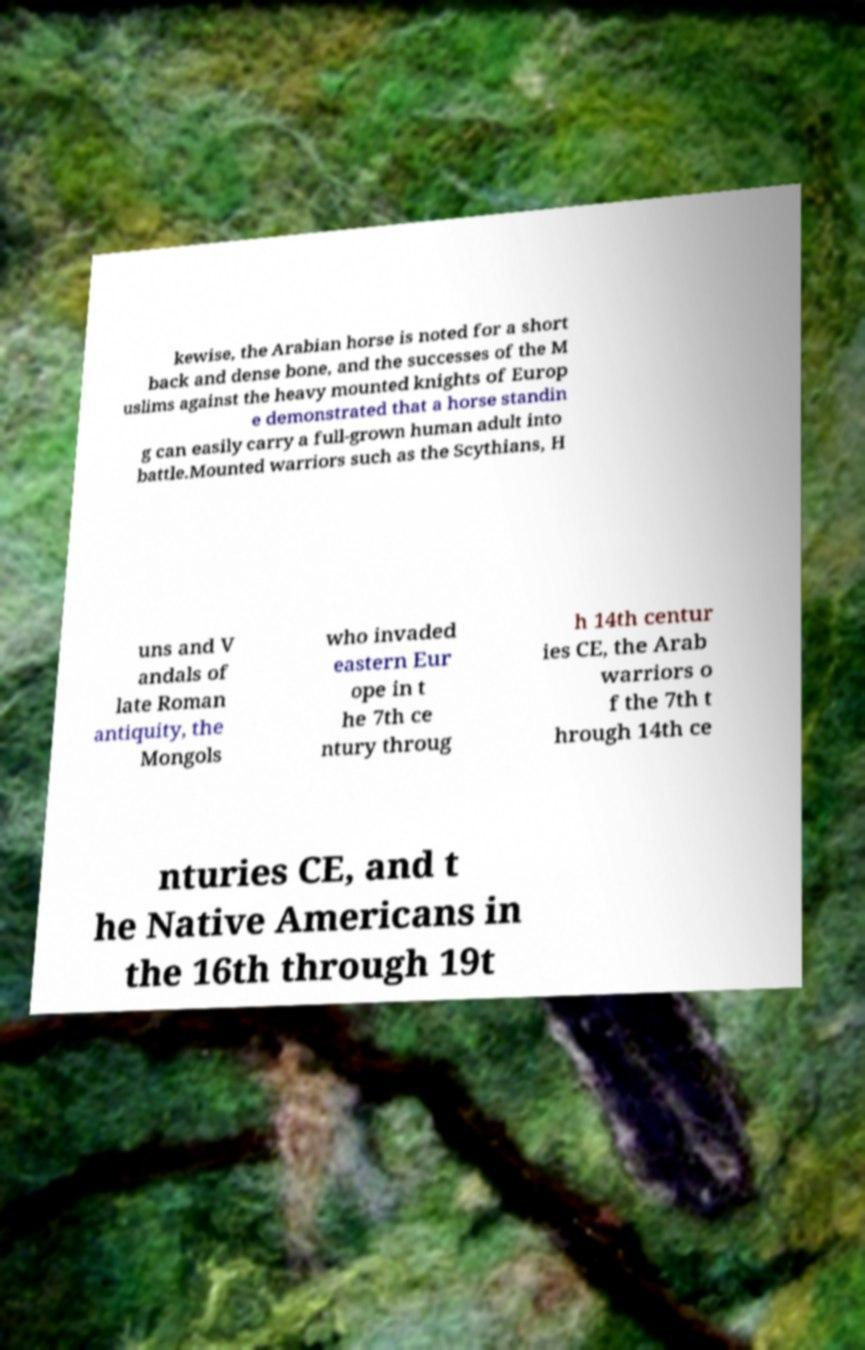What messages or text are displayed in this image? I need them in a readable, typed format. kewise, the Arabian horse is noted for a short back and dense bone, and the successes of the M uslims against the heavy mounted knights of Europ e demonstrated that a horse standin g can easily carry a full-grown human adult into battle.Mounted warriors such as the Scythians, H uns and V andals of late Roman antiquity, the Mongols who invaded eastern Eur ope in t he 7th ce ntury throug h 14th centur ies CE, the Arab warriors o f the 7th t hrough 14th ce nturies CE, and t he Native Americans in the 16th through 19t 